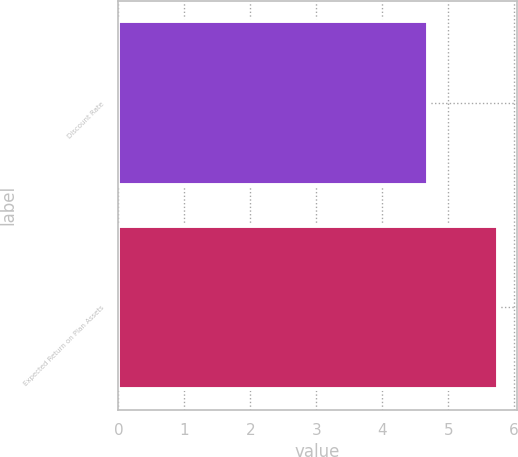Convert chart to OTSL. <chart><loc_0><loc_0><loc_500><loc_500><bar_chart><fcel>Discount Rate<fcel>Expected Return on Plan Assets<nl><fcel>4.7<fcel>5.75<nl></chart> 